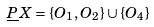Convert formula to latex. <formula><loc_0><loc_0><loc_500><loc_500>\underline { P } X = \{ O _ { 1 } , O _ { 2 } \} \cup \{ O _ { 4 } \}</formula> 